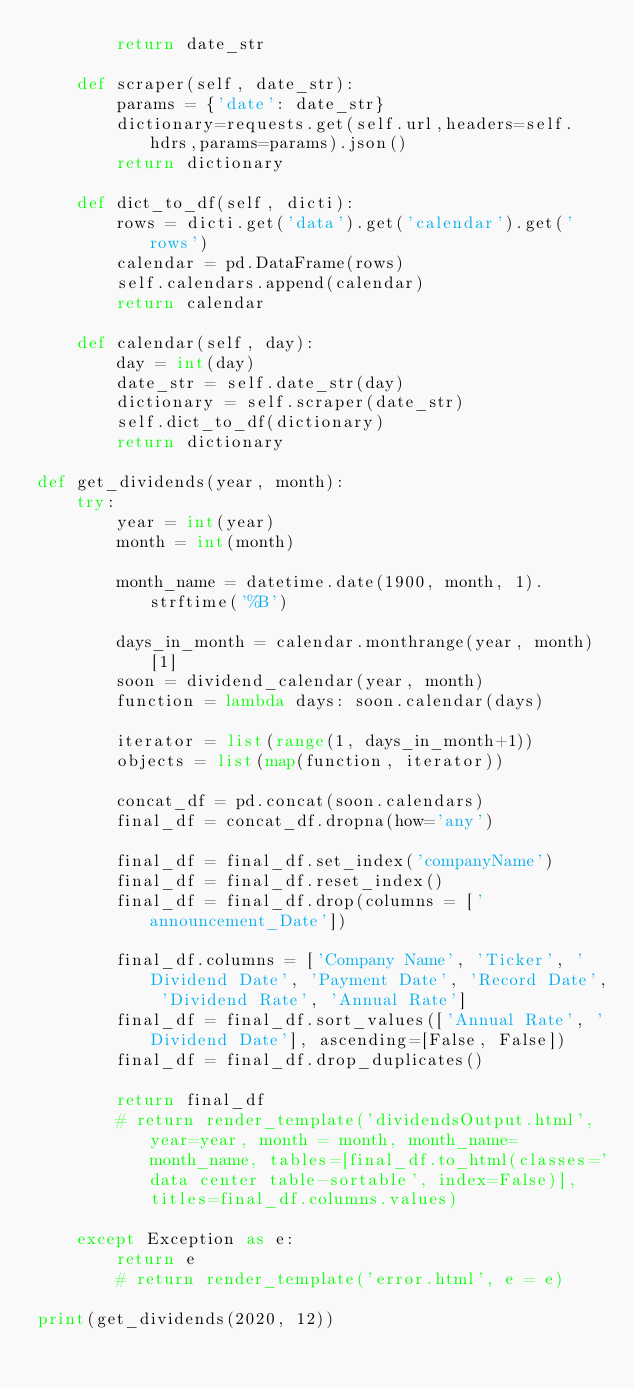<code> <loc_0><loc_0><loc_500><loc_500><_Python_>        return date_str
    
    def scraper(self, date_str):
        params = {'date': date_str}
        dictionary=requests.get(self.url,headers=self.hdrs,params=params).json()
        return dictionary
    
    def dict_to_df(self, dicti):        
        rows = dicti.get('data').get('calendar').get('rows')
        calendar = pd.DataFrame(rows)
        self.calendars.append(calendar)
        return calendar
    
    def calendar(self, day):
        day = int(day)
        date_str = self.date_str(day)      
        dictionary = self.scraper(date_str)
        self.dict_to_df(dictionary)          
        return dictionary
           
def get_dividends(year, month):
    try:
        year = int(year)
        month = int(month)

        month_name = datetime.date(1900, month, 1).strftime('%B')

        days_in_month = calendar.monthrange(year, month)[1]
        soon = dividend_calendar(year, month)
        function = lambda days: soon.calendar(days)
        
        iterator = list(range(1, days_in_month+1))
        objects = list(map(function, iterator))
        
        concat_df = pd.concat(soon.calendars)
        final_df = concat_df.dropna(how='any')
        
        final_df = final_df.set_index('companyName')
        final_df = final_df.reset_index()
        final_df = final_df.drop(columns = ['announcement_Date'])
        
        final_df.columns = ['Company Name', 'Ticker', 'Dividend Date', 'Payment Date', 'Record Date', 'Dividend Rate', 'Annual Rate']
        final_df = final_df.sort_values(['Annual Rate', 'Dividend Date'], ascending=[False, False])
        final_df = final_df.drop_duplicates()
        
        return final_df
        # return render_template('dividendsOutput.html', year=year, month = month, month_name=month_name, tables=[final_df.to_html(classes='data center table-sortable', index=False)], titles=final_df.columns.values)
    
    except Exception as e:
        return e
        # return render_template('error.html', e = e)

print(get_dividends(2020, 12))
</code> 